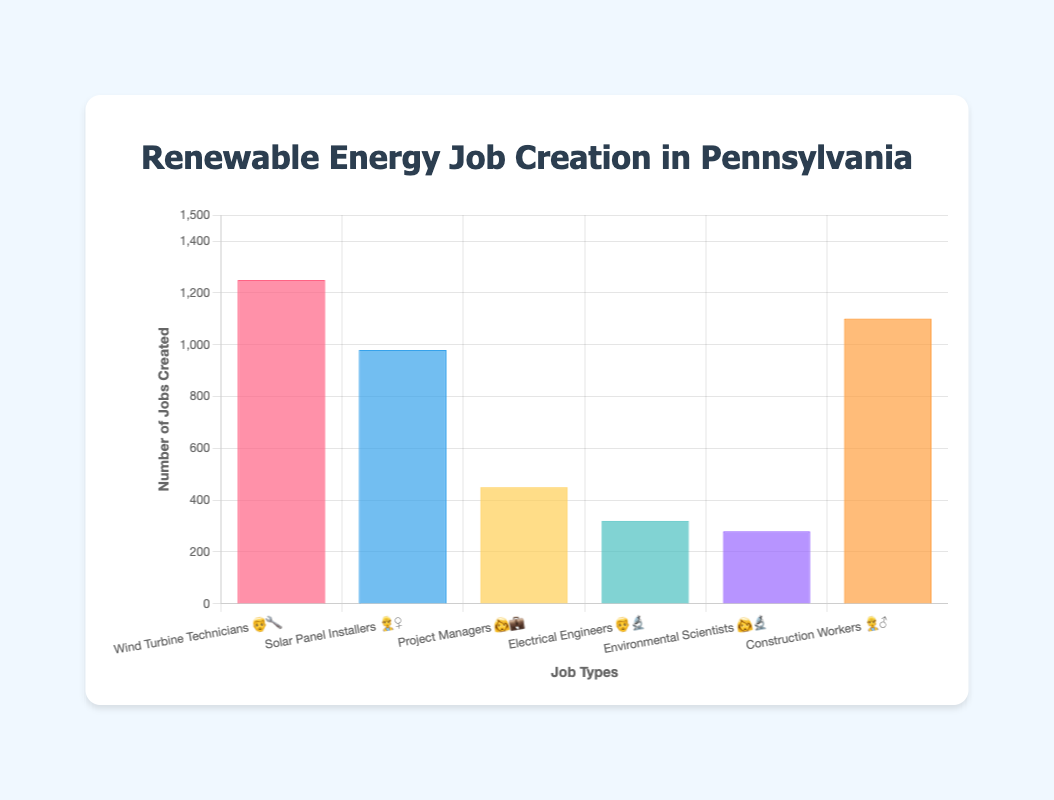How many jobs have been created for Wind Turbine Technicians 👨‍🔧? The bar labeled "Wind Turbine Technicians 👨‍🔧" shows 1250 jobs created.
Answer: 1250 Which job type has the least number of jobs created? The bar labeled "Environmental Scientists 👩‍🔬" shows the smallest value, which is 280 jobs created.
Answer: Environmental Scientists 👩‍🔬 What is the total number of jobs created across all job types? Sum the values from all bars: 1250 (Wind Turbine Technicians) + 980 (Solar Panel Installers) + 450 (Project Managers) + 320 (Electrical Engineers) + 280 (Environmental Scientists) + 1100 (Construction Workers) = 4380.
Answer: 4380 How many more jobs were created for Construction Workers 👷‍♂️ compared to Electrical Engineers 👨‍🔬? Find the difference between the jobs created for Construction Workers and Electrical Engineers: 1100 (Construction Workers) - 320 (Electrical Engineers) = 780.
Answer: 780 Which job type has the second highest number of jobs created? The second tallest bar belongs to "Solar Panel Installers 👷‍♀️" with 980 jobs created.
Answer: Solar Panel Installers 👷‍♀️ What is the average number of jobs created across all job types? Calculate the average by summing all the jobs created and dividing by the number of job types: (1250 + 980 + 450 + 320 + 280 + 1100) / 6 ≈ 730.
Answer: 730 How many job types have more than 500 jobs created? Count the bars with values greater than 500: Wind Turbine Technicians (1250), Solar Panel Installers (980), and Construction Workers (1100). There are 3 job types.
Answer: 3 Which two job types have a combined total of less than 600 jobs created? "Environmental Scientists 👩‍🔬" (280) and "Electrical Engineers 👨‍🔬" (320) together have 280 + 320 = 600 jobs created. As 600 is exactly the limit, they just make the cut.
Answer: Environmental Scientists 👩‍🔬 and Electrical Engineers 👨‍🔬 